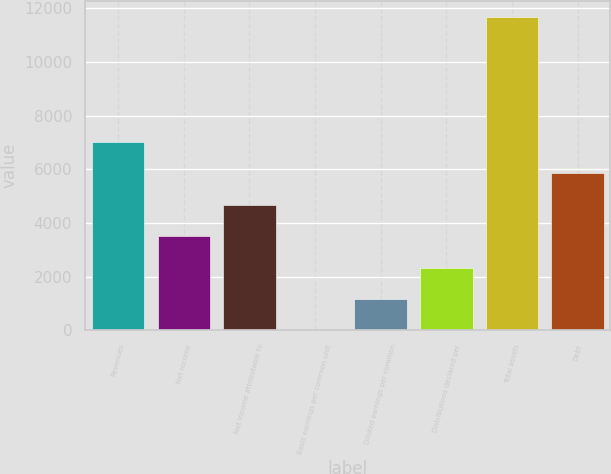Convert chart. <chart><loc_0><loc_0><loc_500><loc_500><bar_chart><fcel>Revenues<fcel>Net income<fcel>Net income attributable to<fcel>Basic earnings per common unit<fcel>Diluted earnings per common<fcel>Distributions declared per<fcel>Total assets<fcel>Debt<nl><fcel>7016.1<fcel>3508.44<fcel>4677.66<fcel>0.78<fcel>1170<fcel>2339.22<fcel>11693<fcel>5846.88<nl></chart> 